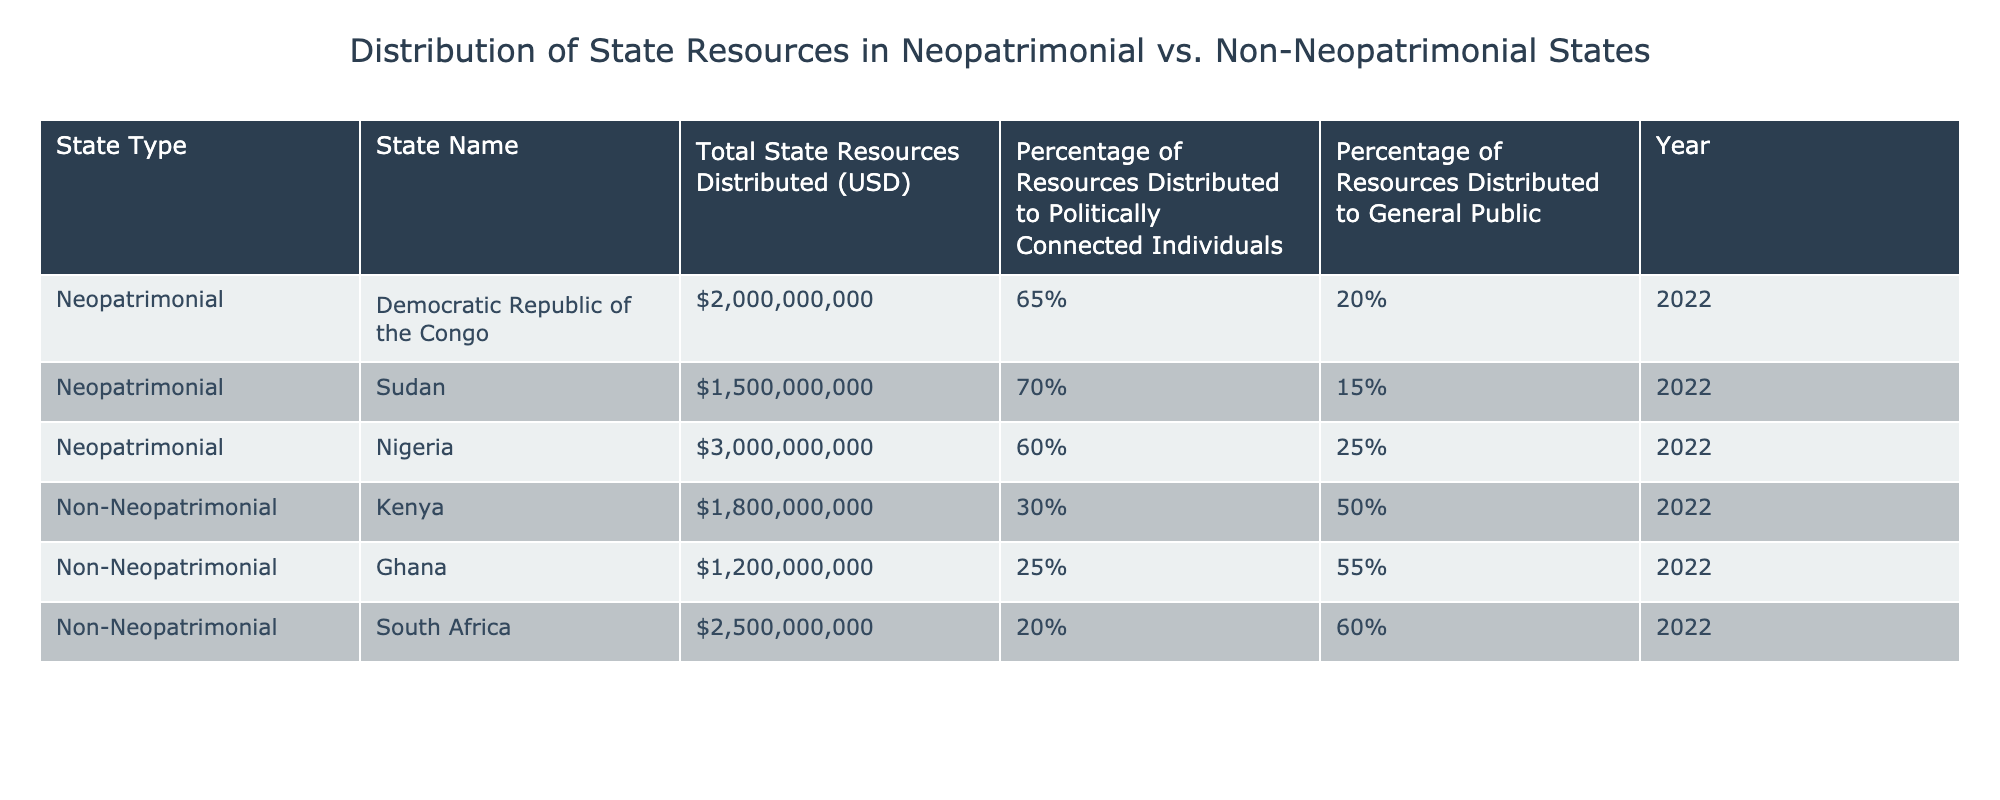What is the total state resources distributed by Nigeria? From the table, we locate Nigeria under the Neopatrimonial state type. The "Total State Resources Distributed (USD)" for Nigeria is listed as 3,000,000,000.
Answer: 3,000,000,000 What percentage of resources in Kenya is distributed to the general public? Referring to the row for Kenya, which is categorized as Non-Neopatrimonial, we find that the "Percentage of Resources Distributed to General Public" is recorded as 50%.
Answer: 50% Which state had the highest percentage of resources distributed to politically connected individuals? Searching through the table, Sudan, under the Neopatrimonial type, shows the highest figure—70% for "Percentage of Resources Distributed to Politically Connected Individuals."
Answer: Sudan Calculate the average percentage of resources distributed to the general public for the Non-Neopatrimonial states. The Non-Neopatrimonial states and their percentages distributed to the general public are 50% (Kenya), 55% (Ghana), and 60% (South Africa). The average is calculated by summing these, which is (50 + 55 + 60) = 165, then dividing by 3 (the number of states), which gives us an average of 55%.
Answer: 55% Is it true that the Democratic Republic of the Congo distributed more than 2 billion USD in state resources? Looking at the row for the Democratic Republic of the Congo, the "Total State Resources Distributed (USD)" is 2,000,000,000, which confirms that it did distribute exactly 2 billion USD, thus the statement is true.
Answer: Yes What is the difference in percentage of resources distributed to politically connected individuals between Sudan and South Africa? Checking the percentages, Sudan has 70% and South Africa has 20% for "Percentage of Resources Distributed to Politically Connected Individuals." To find the difference, we subtract: 70% - 20% = 50%.
Answer: 50% Which Non-Neopatrimonial state received the least total state resources? By examining the total state resources for Non-Neopatrimonial states, Ghana has the lowest figure of 1,200,000,000 USD, less than Kenya (1,800,000,000 USD) and South Africa (2,500,000,000 USD).
Answer: Ghana Does Nigeria have a higher total state resource distribution than Sudan? Total state resource distribution for Nigeria is 3 billion USD and for Sudan it is 1.5 billion USD. 3 billion is greater than 1.5 billion, confirming that the statement is true.
Answer: Yes 